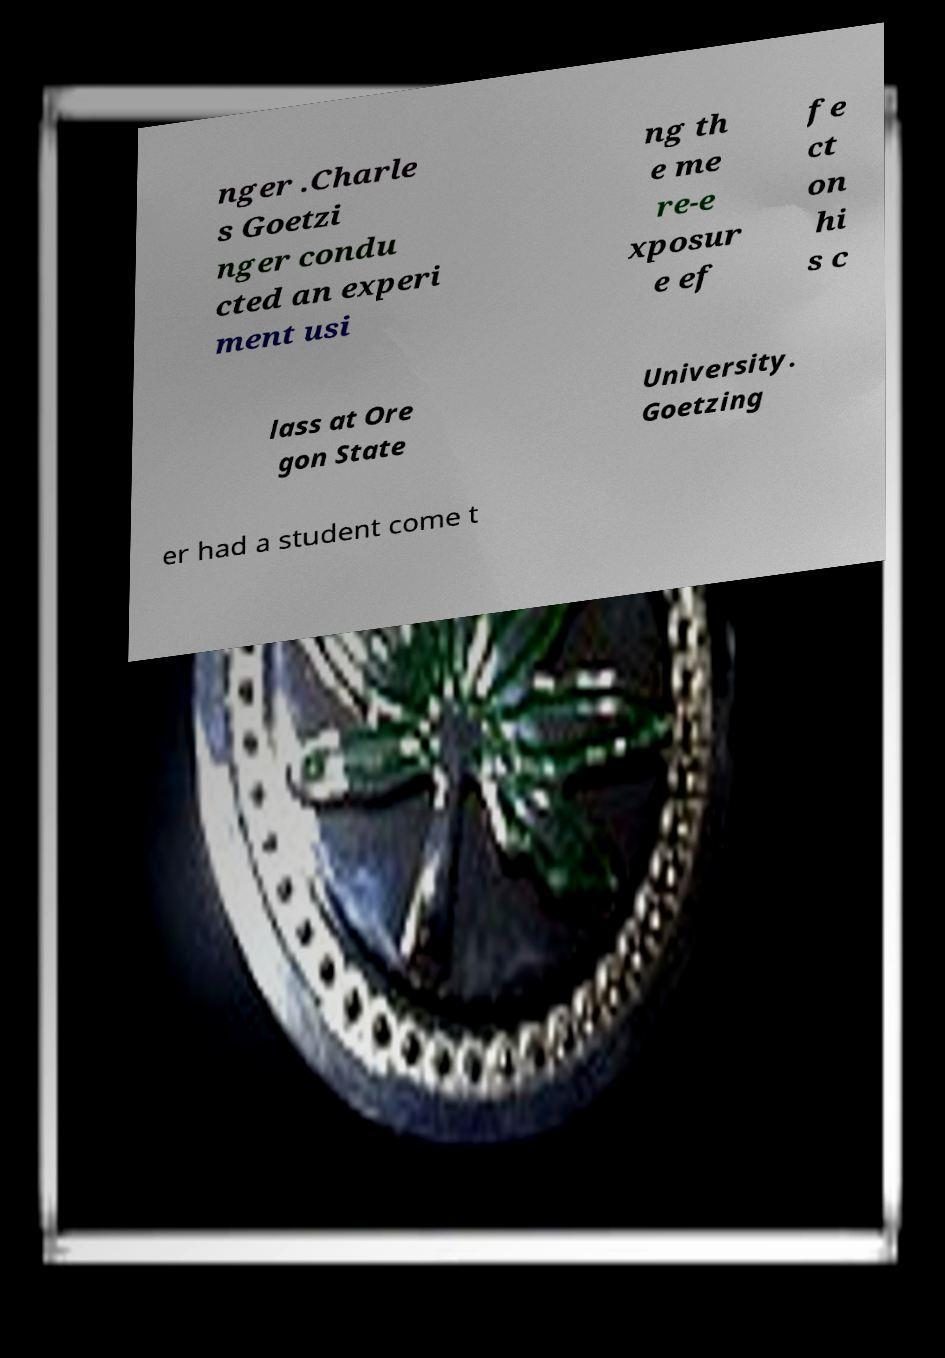Could you assist in decoding the text presented in this image and type it out clearly? nger .Charle s Goetzi nger condu cted an experi ment usi ng th e me re-e xposur e ef fe ct on hi s c lass at Ore gon State University. Goetzing er had a student come t 